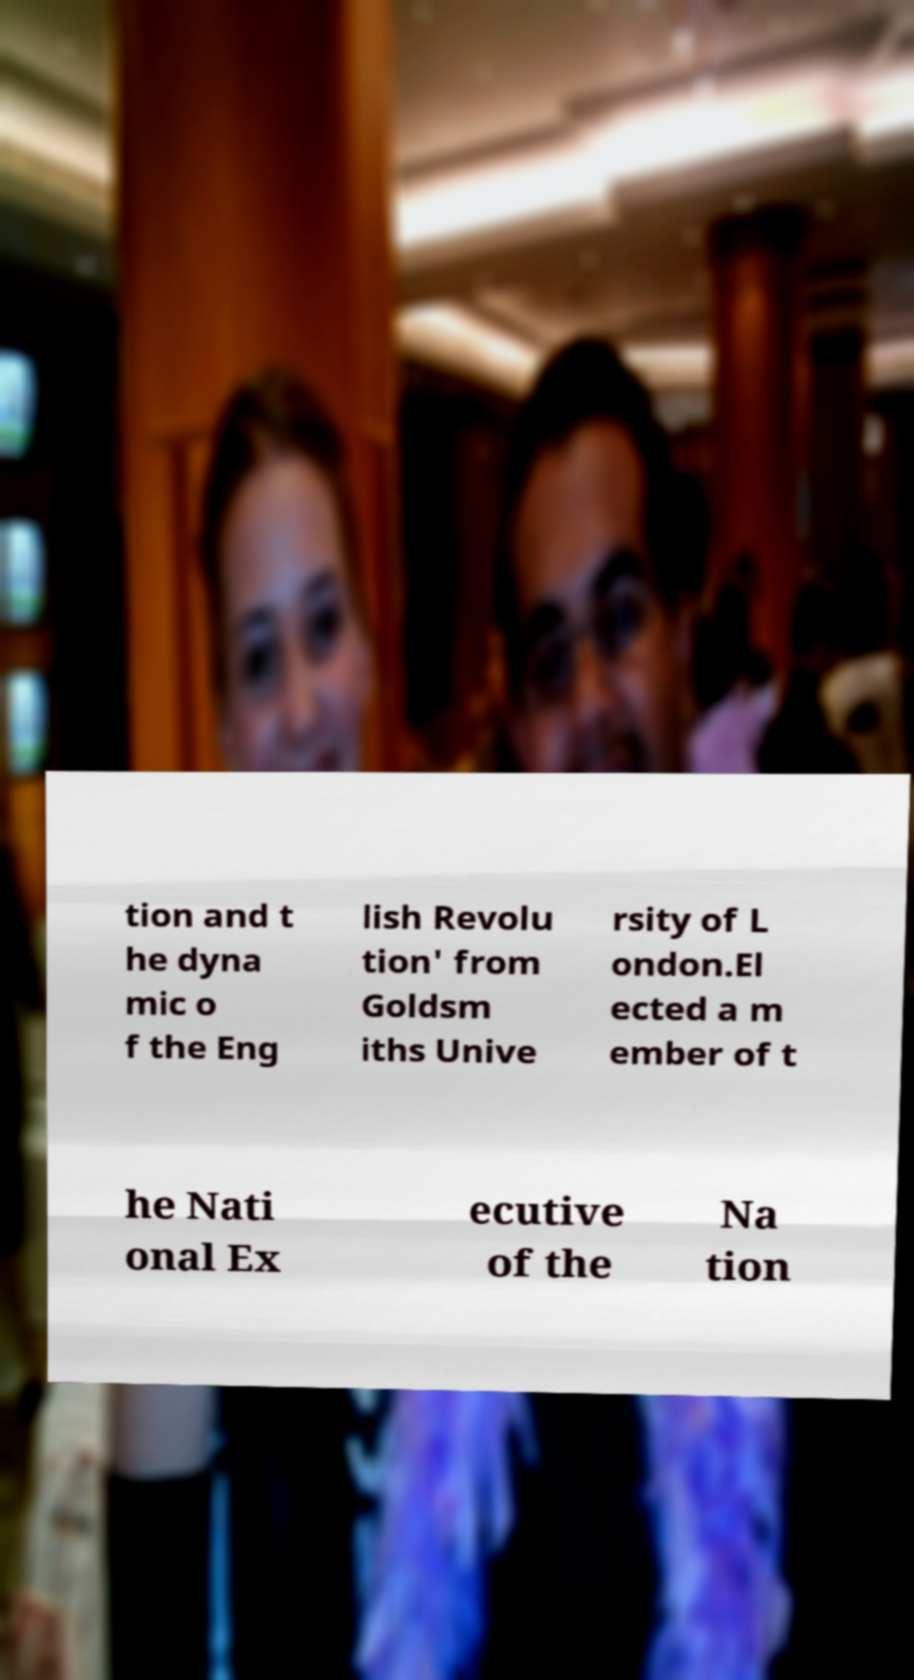Could you extract and type out the text from this image? tion and t he dyna mic o f the Eng lish Revolu tion' from Goldsm iths Unive rsity of L ondon.El ected a m ember of t he Nati onal Ex ecutive of the Na tion 